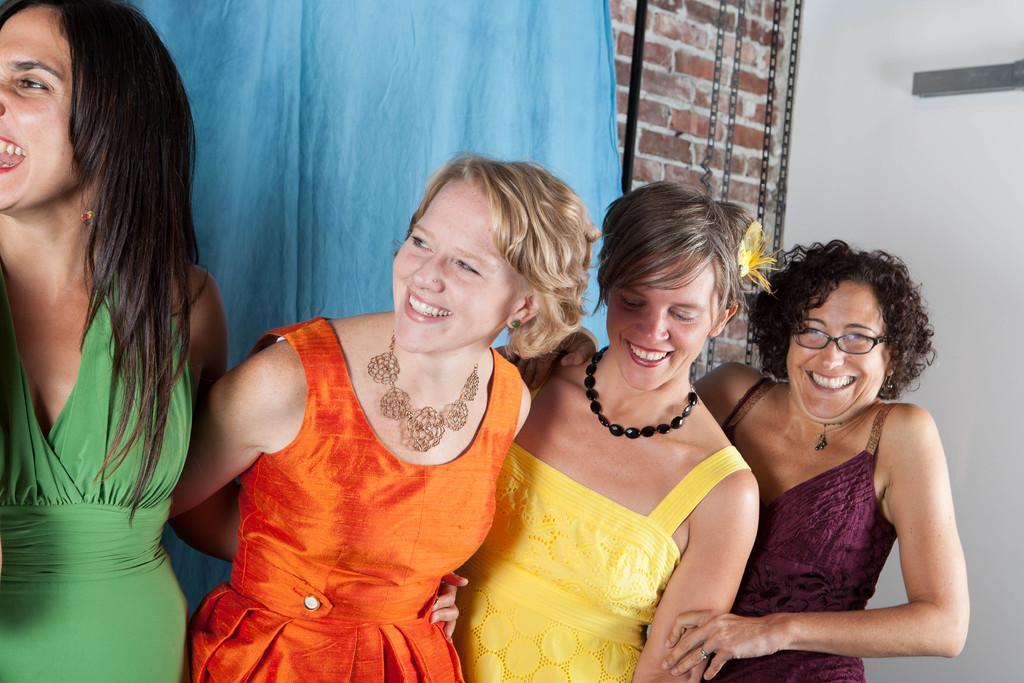Describe this image in one or two sentences. In this image we can see four ladies, behind them there is a cloth, and the wall. 